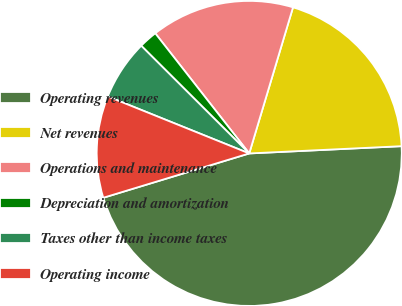Convert chart. <chart><loc_0><loc_0><loc_500><loc_500><pie_chart><fcel>Operating revenues<fcel>Net revenues<fcel>Operations and maintenance<fcel>Depreciation and amortization<fcel>Taxes other than income taxes<fcel>Operating income<nl><fcel>46.07%<fcel>19.61%<fcel>15.2%<fcel>1.96%<fcel>6.38%<fcel>10.79%<nl></chart> 